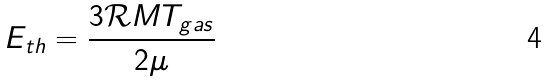<formula> <loc_0><loc_0><loc_500><loc_500>E _ { t h } = \frac { 3 \mathcal { R } M T _ { g a s } } { 2 \mu }</formula> 